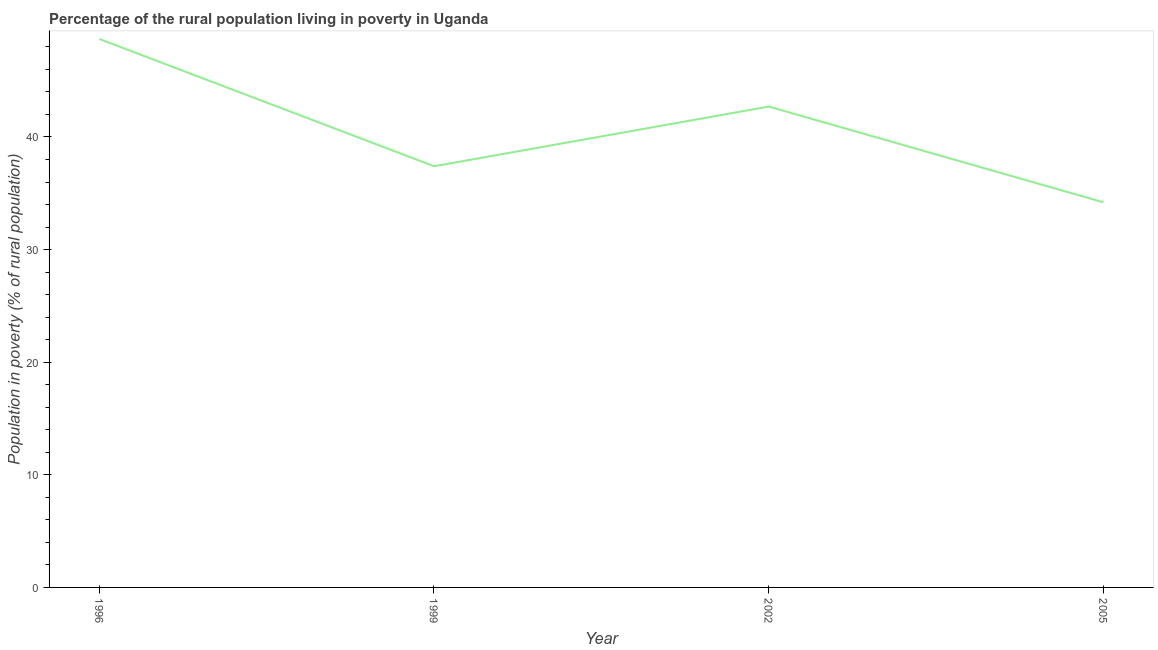What is the percentage of rural population living below poverty line in 1999?
Your response must be concise. 37.4. Across all years, what is the maximum percentage of rural population living below poverty line?
Your response must be concise. 48.7. Across all years, what is the minimum percentage of rural population living below poverty line?
Your answer should be very brief. 34.2. What is the sum of the percentage of rural population living below poverty line?
Your response must be concise. 163. What is the average percentage of rural population living below poverty line per year?
Provide a short and direct response. 40.75. What is the median percentage of rural population living below poverty line?
Give a very brief answer. 40.05. What is the ratio of the percentage of rural population living below poverty line in 2002 to that in 2005?
Offer a terse response. 1.25. Is the difference between the percentage of rural population living below poverty line in 1996 and 2005 greater than the difference between any two years?
Your response must be concise. Yes. What is the difference between the highest and the second highest percentage of rural population living below poverty line?
Your answer should be very brief. 6. Is the sum of the percentage of rural population living below poverty line in 1999 and 2005 greater than the maximum percentage of rural population living below poverty line across all years?
Offer a very short reply. Yes. In how many years, is the percentage of rural population living below poverty line greater than the average percentage of rural population living below poverty line taken over all years?
Keep it short and to the point. 2. Does the percentage of rural population living below poverty line monotonically increase over the years?
Your answer should be very brief. No. How many years are there in the graph?
Ensure brevity in your answer.  4. What is the difference between two consecutive major ticks on the Y-axis?
Offer a terse response. 10. Are the values on the major ticks of Y-axis written in scientific E-notation?
Your answer should be very brief. No. What is the title of the graph?
Offer a terse response. Percentage of the rural population living in poverty in Uganda. What is the label or title of the Y-axis?
Ensure brevity in your answer.  Population in poverty (% of rural population). What is the Population in poverty (% of rural population) of 1996?
Keep it short and to the point. 48.7. What is the Population in poverty (% of rural population) of 1999?
Provide a succinct answer. 37.4. What is the Population in poverty (% of rural population) of 2002?
Your response must be concise. 42.7. What is the Population in poverty (% of rural population) of 2005?
Offer a terse response. 34.2. What is the difference between the Population in poverty (% of rural population) in 1996 and 1999?
Give a very brief answer. 11.3. What is the difference between the Population in poverty (% of rural population) in 1999 and 2002?
Keep it short and to the point. -5.3. What is the difference between the Population in poverty (% of rural population) in 1999 and 2005?
Provide a short and direct response. 3.2. What is the difference between the Population in poverty (% of rural population) in 2002 and 2005?
Provide a short and direct response. 8.5. What is the ratio of the Population in poverty (% of rural population) in 1996 to that in 1999?
Offer a very short reply. 1.3. What is the ratio of the Population in poverty (% of rural population) in 1996 to that in 2002?
Your answer should be very brief. 1.14. What is the ratio of the Population in poverty (% of rural population) in 1996 to that in 2005?
Ensure brevity in your answer.  1.42. What is the ratio of the Population in poverty (% of rural population) in 1999 to that in 2002?
Provide a short and direct response. 0.88. What is the ratio of the Population in poverty (% of rural population) in 1999 to that in 2005?
Offer a terse response. 1.09. What is the ratio of the Population in poverty (% of rural population) in 2002 to that in 2005?
Ensure brevity in your answer.  1.25. 